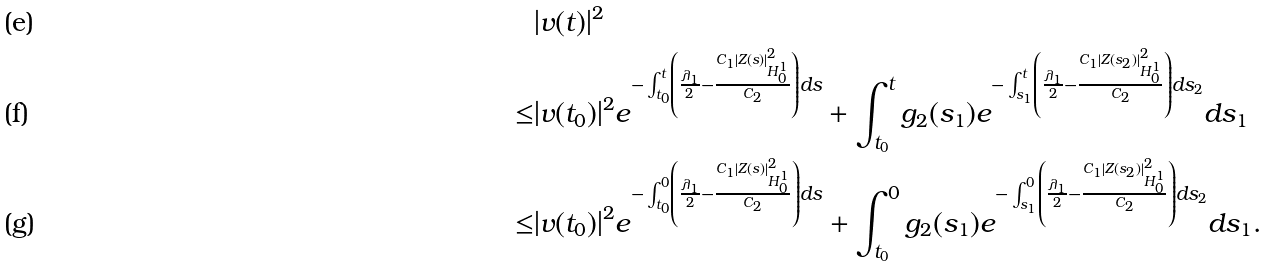<formula> <loc_0><loc_0><loc_500><loc_500>& | v ( t ) | ^ { 2 } \\ \leq & | v ( t _ { 0 } ) | ^ { 2 } e ^ { - \int _ { t _ { 0 } } ^ { t } \left ( \frac { \lambda _ { 1 } } { 2 } - \frac { C _ { 1 } | Z ( s ) | _ { H _ { 0 } ^ { 1 } } ^ { 2 } } { C _ { 2 } } \right ) d s } + \int _ { t _ { 0 } } ^ { t } g _ { 2 } ( s _ { 1 } ) e ^ { - \int _ { s _ { 1 } } ^ { t } \left ( \frac { \lambda _ { 1 } } { 2 } - \frac { C _ { 1 } | Z ( s _ { 2 } ) | _ { H _ { 0 } ^ { 1 } } ^ { 2 } } { C _ { 2 } } \right ) d s _ { 2 } } d s _ { 1 } \\ \leq & | v ( t _ { 0 } ) | ^ { 2 } e ^ { - \int _ { t _ { 0 } } ^ { 0 } \left ( \frac { \lambda _ { 1 } } { 2 } - \frac { C _ { 1 } | Z ( s ) | _ { H _ { 0 } ^ { 1 } } ^ { 2 } } { C _ { 2 } } \right ) d s } + \int _ { t _ { 0 } } ^ { 0 } g _ { 2 } ( s _ { 1 } ) e ^ { - \int _ { s _ { 1 } } ^ { 0 } \left ( \frac { \lambda _ { 1 } } { 2 } - \frac { C _ { 1 } | Z ( s _ { 2 } ) | _ { H _ { 0 } ^ { 1 } } ^ { 2 } } { C _ { 2 } } \right ) d s _ { 2 } } d s _ { 1 } .</formula> 